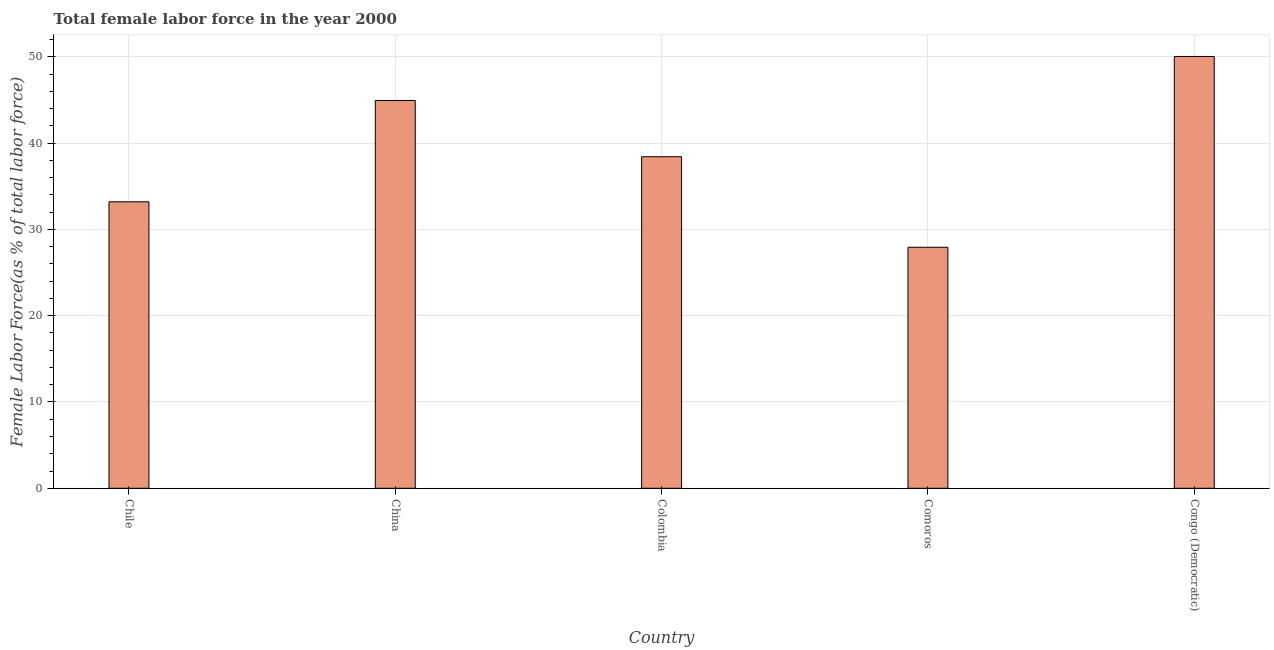Does the graph contain any zero values?
Provide a succinct answer. No. Does the graph contain grids?
Provide a short and direct response. Yes. What is the title of the graph?
Provide a short and direct response. Total female labor force in the year 2000. What is the label or title of the Y-axis?
Offer a terse response. Female Labor Force(as % of total labor force). What is the total female labor force in China?
Ensure brevity in your answer.  44.95. Across all countries, what is the maximum total female labor force?
Give a very brief answer. 50.05. Across all countries, what is the minimum total female labor force?
Provide a succinct answer. 27.93. In which country was the total female labor force maximum?
Provide a short and direct response. Congo (Democratic). In which country was the total female labor force minimum?
Your answer should be compact. Comoros. What is the sum of the total female labor force?
Offer a terse response. 194.55. What is the difference between the total female labor force in Chile and Congo (Democratic)?
Offer a terse response. -16.84. What is the average total female labor force per country?
Ensure brevity in your answer.  38.91. What is the median total female labor force?
Provide a succinct answer. 38.43. What is the ratio of the total female labor force in China to that in Comoros?
Provide a short and direct response. 1.61. What is the difference between the highest and the second highest total female labor force?
Offer a very short reply. 5.1. Is the sum of the total female labor force in Chile and Colombia greater than the maximum total female labor force across all countries?
Make the answer very short. Yes. What is the difference between the highest and the lowest total female labor force?
Offer a very short reply. 22.11. Are all the bars in the graph horizontal?
Provide a succinct answer. No. How many countries are there in the graph?
Give a very brief answer. 5. What is the difference between two consecutive major ticks on the Y-axis?
Your response must be concise. 10. What is the Female Labor Force(as % of total labor force) in Chile?
Ensure brevity in your answer.  33.2. What is the Female Labor Force(as % of total labor force) of China?
Provide a succinct answer. 44.95. What is the Female Labor Force(as % of total labor force) of Colombia?
Keep it short and to the point. 38.43. What is the Female Labor Force(as % of total labor force) in Comoros?
Provide a short and direct response. 27.93. What is the Female Labor Force(as % of total labor force) in Congo (Democratic)?
Your answer should be compact. 50.05. What is the difference between the Female Labor Force(as % of total labor force) in Chile and China?
Provide a short and direct response. -11.74. What is the difference between the Female Labor Force(as % of total labor force) in Chile and Colombia?
Your response must be concise. -5.22. What is the difference between the Female Labor Force(as % of total labor force) in Chile and Comoros?
Provide a short and direct response. 5.27. What is the difference between the Female Labor Force(as % of total labor force) in Chile and Congo (Democratic)?
Offer a terse response. -16.84. What is the difference between the Female Labor Force(as % of total labor force) in China and Colombia?
Offer a very short reply. 6.52. What is the difference between the Female Labor Force(as % of total labor force) in China and Comoros?
Provide a short and direct response. 17.01. What is the difference between the Female Labor Force(as % of total labor force) in China and Congo (Democratic)?
Give a very brief answer. -5.1. What is the difference between the Female Labor Force(as % of total labor force) in Colombia and Comoros?
Your answer should be very brief. 10.49. What is the difference between the Female Labor Force(as % of total labor force) in Colombia and Congo (Democratic)?
Provide a short and direct response. -11.62. What is the difference between the Female Labor Force(as % of total labor force) in Comoros and Congo (Democratic)?
Provide a short and direct response. -22.11. What is the ratio of the Female Labor Force(as % of total labor force) in Chile to that in China?
Provide a short and direct response. 0.74. What is the ratio of the Female Labor Force(as % of total labor force) in Chile to that in Colombia?
Your answer should be compact. 0.86. What is the ratio of the Female Labor Force(as % of total labor force) in Chile to that in Comoros?
Your response must be concise. 1.19. What is the ratio of the Female Labor Force(as % of total labor force) in Chile to that in Congo (Democratic)?
Keep it short and to the point. 0.66. What is the ratio of the Female Labor Force(as % of total labor force) in China to that in Colombia?
Your answer should be very brief. 1.17. What is the ratio of the Female Labor Force(as % of total labor force) in China to that in Comoros?
Give a very brief answer. 1.61. What is the ratio of the Female Labor Force(as % of total labor force) in China to that in Congo (Democratic)?
Your answer should be very brief. 0.9. What is the ratio of the Female Labor Force(as % of total labor force) in Colombia to that in Comoros?
Your answer should be very brief. 1.38. What is the ratio of the Female Labor Force(as % of total labor force) in Colombia to that in Congo (Democratic)?
Give a very brief answer. 0.77. What is the ratio of the Female Labor Force(as % of total labor force) in Comoros to that in Congo (Democratic)?
Ensure brevity in your answer.  0.56. 